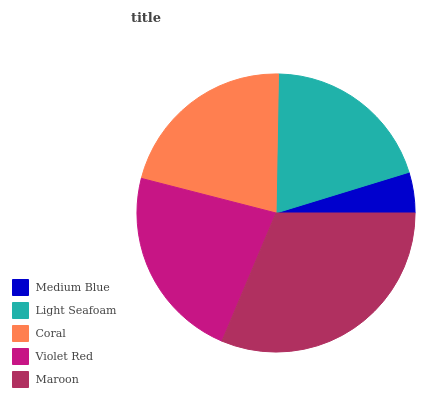Is Medium Blue the minimum?
Answer yes or no. Yes. Is Maroon the maximum?
Answer yes or no. Yes. Is Light Seafoam the minimum?
Answer yes or no. No. Is Light Seafoam the maximum?
Answer yes or no. No. Is Light Seafoam greater than Medium Blue?
Answer yes or no. Yes. Is Medium Blue less than Light Seafoam?
Answer yes or no. Yes. Is Medium Blue greater than Light Seafoam?
Answer yes or no. No. Is Light Seafoam less than Medium Blue?
Answer yes or no. No. Is Coral the high median?
Answer yes or no. Yes. Is Coral the low median?
Answer yes or no. Yes. Is Medium Blue the high median?
Answer yes or no. No. Is Medium Blue the low median?
Answer yes or no. No. 